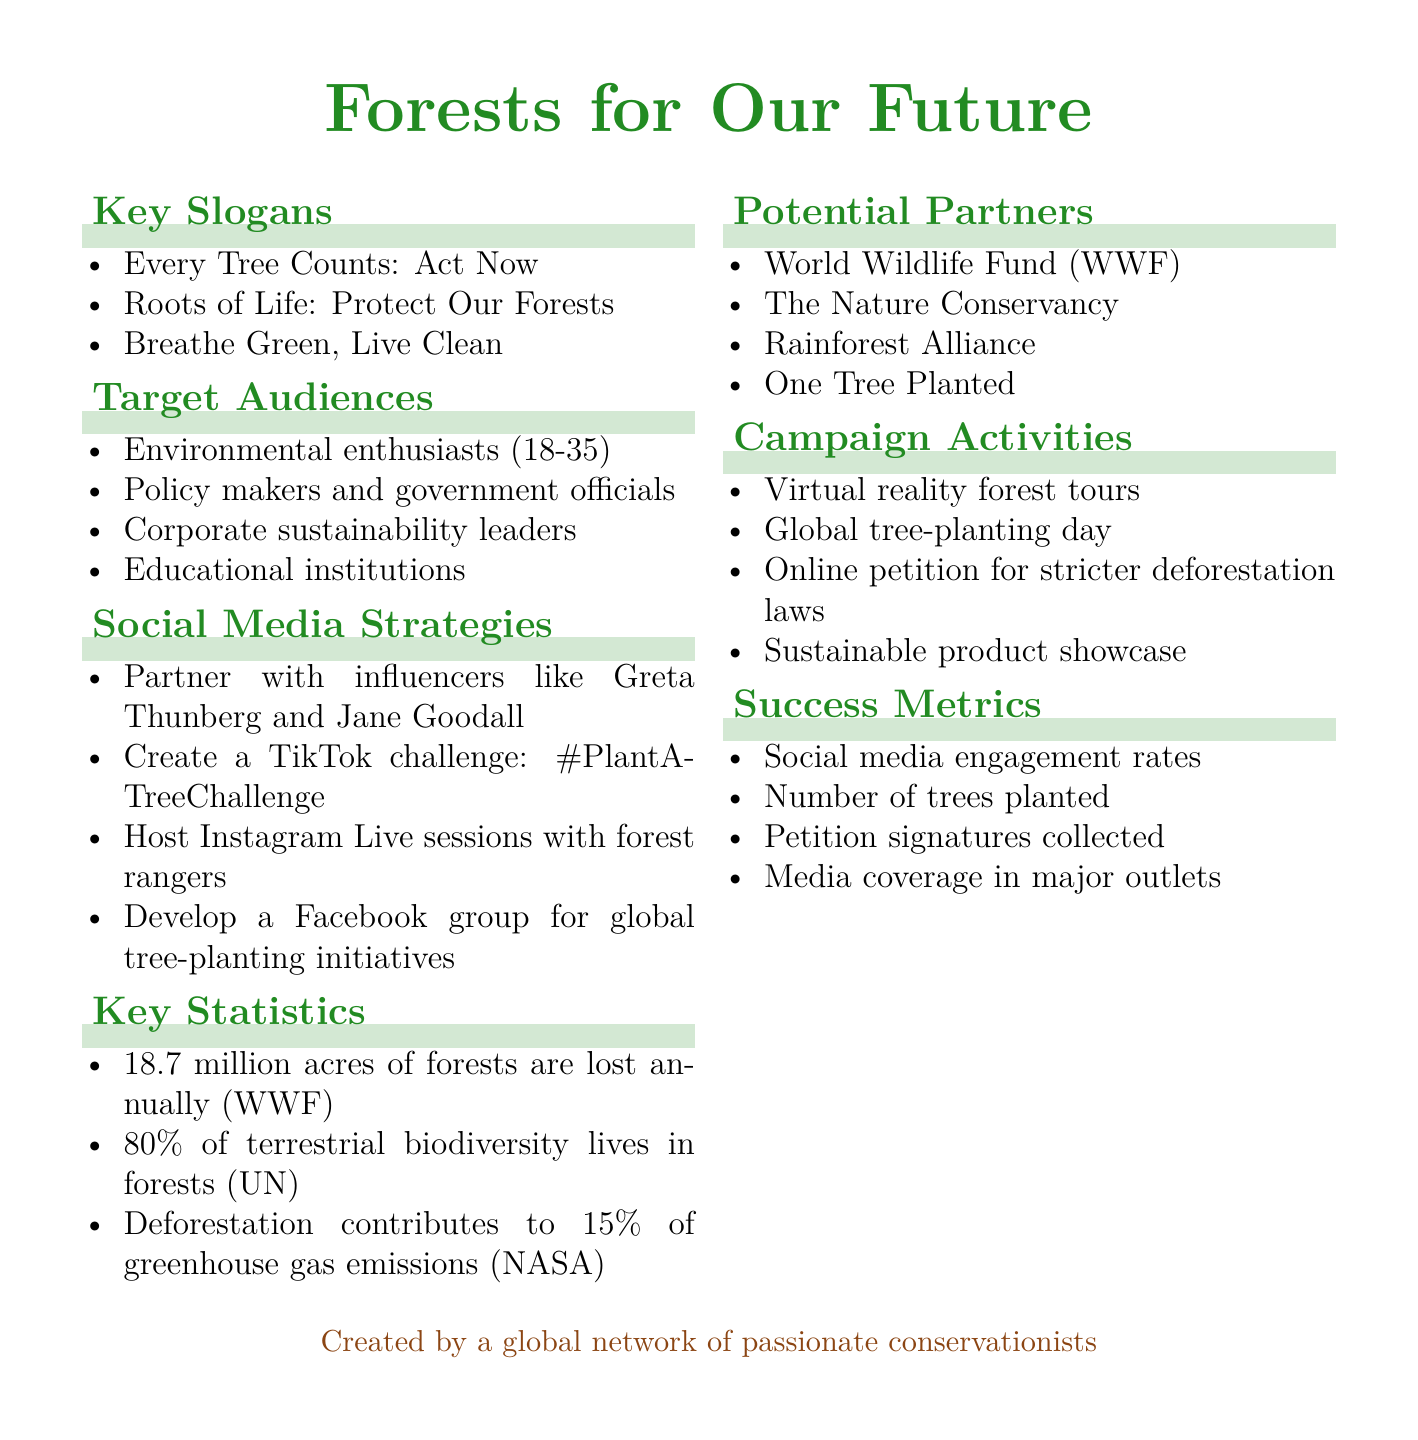What is the campaign title? The campaign title is mentioned prominently at the beginning of the document.
Answer: Forests for Our Future How many key slogans are listed in the document? The number of key slogans can be determined by counting the items under "Key Slogans."
Answer: 3 What is one of the target audiences? The target audiences are specified in a list format; any one item can be selected.
Answer: Environmental enthusiasts (18-35) Which social media strategy involves influencers? The social media strategies include various tactics; this one specifies working with influencers.
Answer: Partner with influencers like Greta Thunberg and Jane Goodall What percentage of terrestrial biodiversity lives in forests? The document provides a specific statistic related to biodiversity in forests.
Answer: 80% Name one potential partner for the campaign. Potential partners are listed in the document; any one name can be selected.
Answer: World Wildlife Fund (WWF) How many campaign activities are mentioned? The total number of activities can be counted from the "Campaign Activities" section.
Answer: 4 What is one of the success metrics? Success metrics are listed, and any listed item can be mentioned as a response.
Answer: Social media engagement rates What is a proposed activity for raising awareness about deforestation? The campaign activities section outlines specific initiatives, one of which can be cited.
Answer: Global tree-planting day 